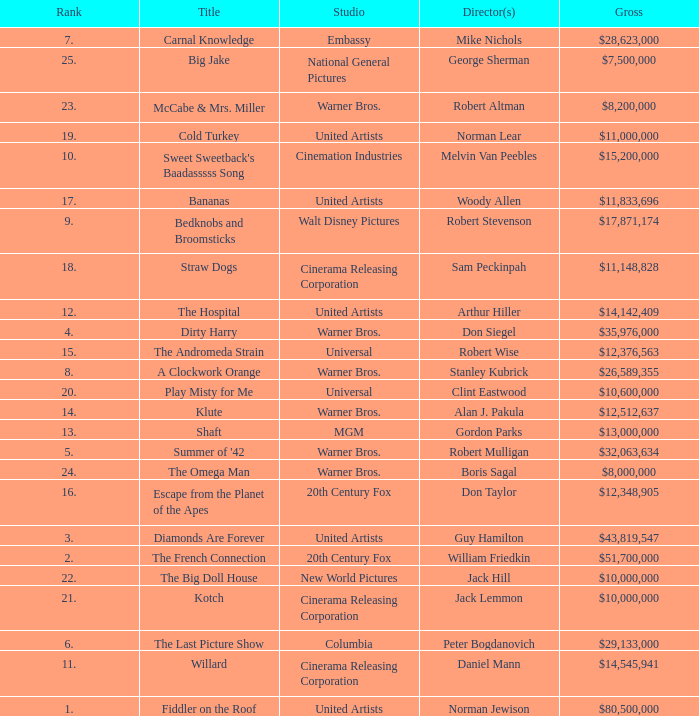What rank has a gross of $35,976,000? 4.0. 